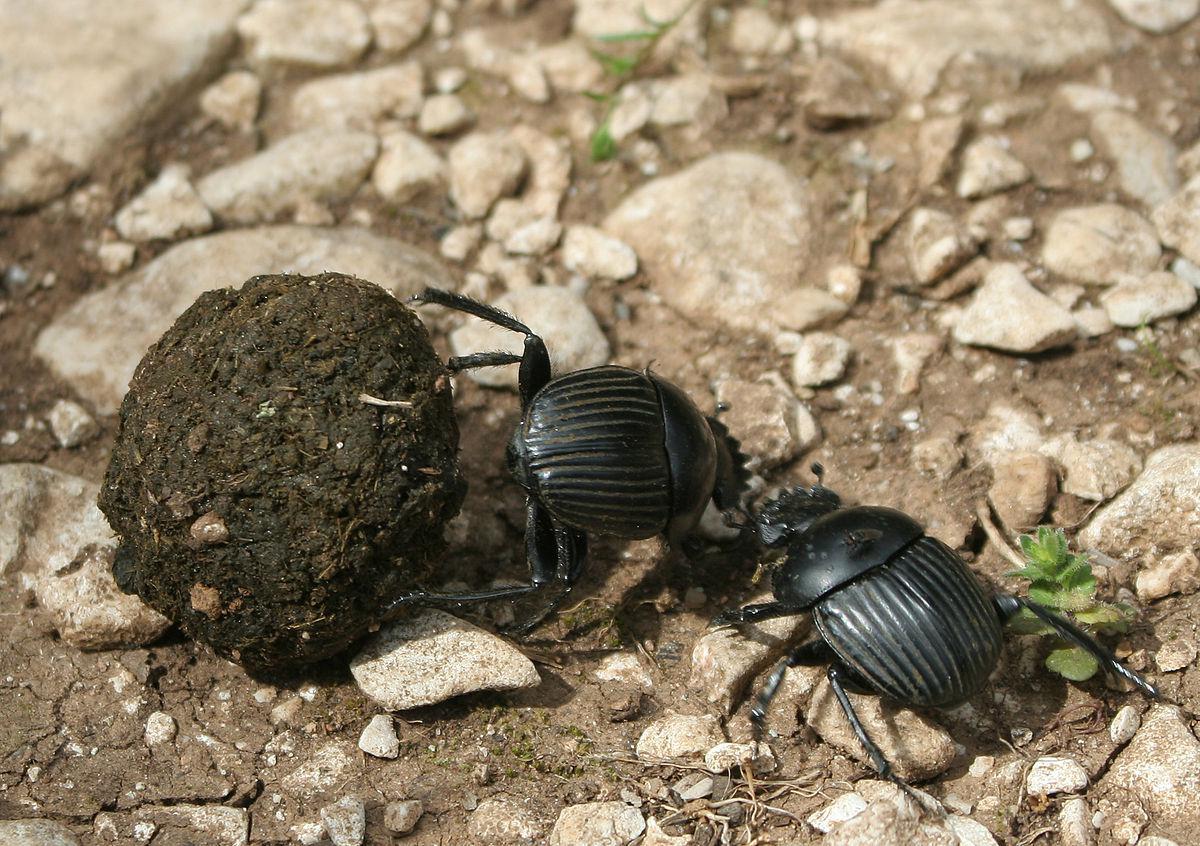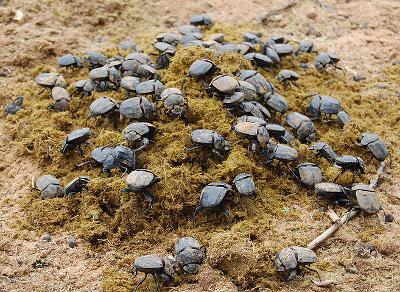The first image is the image on the left, the second image is the image on the right. Examine the images to the left and right. Is the description "The left image contains two beetles." accurate? Answer yes or no. Yes. The first image is the image on the left, the second image is the image on the right. For the images shown, is this caption "There are at most two scarab beetles." true? Answer yes or no. No. 